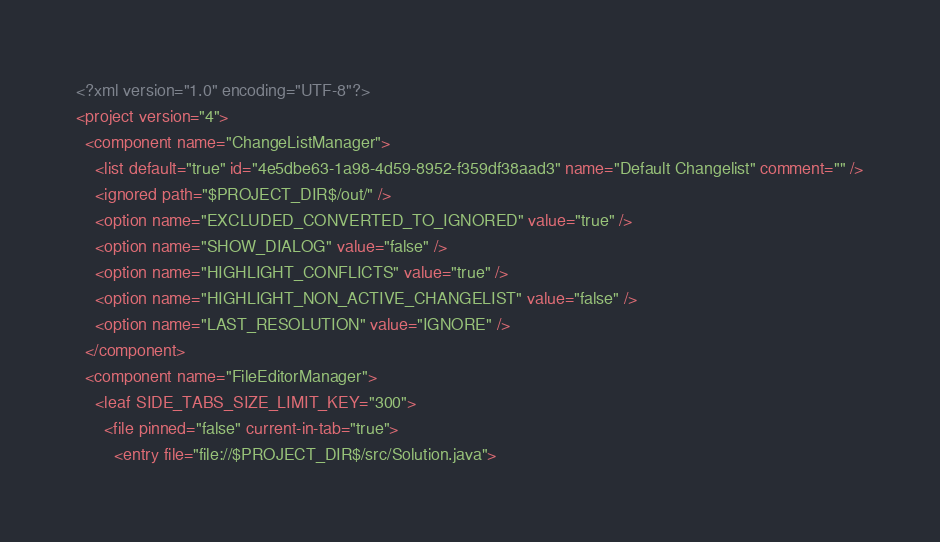Convert code to text. <code><loc_0><loc_0><loc_500><loc_500><_XML_><?xml version="1.0" encoding="UTF-8"?>
<project version="4">
  <component name="ChangeListManager">
    <list default="true" id="4e5dbe63-1a98-4d59-8952-f359df38aad3" name="Default Changelist" comment="" />
    <ignored path="$PROJECT_DIR$/out/" />
    <option name="EXCLUDED_CONVERTED_TO_IGNORED" value="true" />
    <option name="SHOW_DIALOG" value="false" />
    <option name="HIGHLIGHT_CONFLICTS" value="true" />
    <option name="HIGHLIGHT_NON_ACTIVE_CHANGELIST" value="false" />
    <option name="LAST_RESOLUTION" value="IGNORE" />
  </component>
  <component name="FileEditorManager">
    <leaf SIDE_TABS_SIZE_LIMIT_KEY="300">
      <file pinned="false" current-in-tab="true">
        <entry file="file://$PROJECT_DIR$/src/Solution.java"></code> 